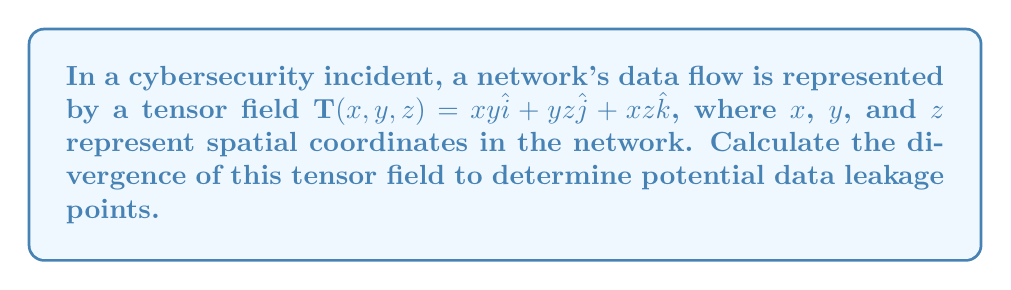Show me your answer to this math problem. To calculate the divergence of the tensor field, we need to follow these steps:

1) The divergence of a tensor field $\mathbf{T}(x,y,z) = T_x\hat{i} + T_y\hat{j} + T_z\hat{k}$ is given by:

   $$\nabla \cdot \mathbf{T} = \frac{\partial T_x}{\partial x} + \frac{\partial T_y}{\partial y} + \frac{\partial T_z}{\partial z}$$

2) In our case:
   $T_x = xy$
   $T_y = yz$
   $T_z = xz$

3) Now, let's calculate each partial derivative:

   $\frac{\partial T_x}{\partial x} = \frac{\partial (xy)}{\partial x} = y$

   $\frac{\partial T_y}{\partial y} = \frac{\partial (yz)}{\partial y} = z$

   $\frac{\partial T_z}{\partial z} = \frac{\partial (xz)}{\partial z} = x$

4) Sum these partial derivatives:

   $$\nabla \cdot \mathbf{T} = y + z + x$$

This result represents the rate at which data is flowing out of (or into) a point in the network, which could indicate potential data leakage points.
Answer: $y + z + x$ 